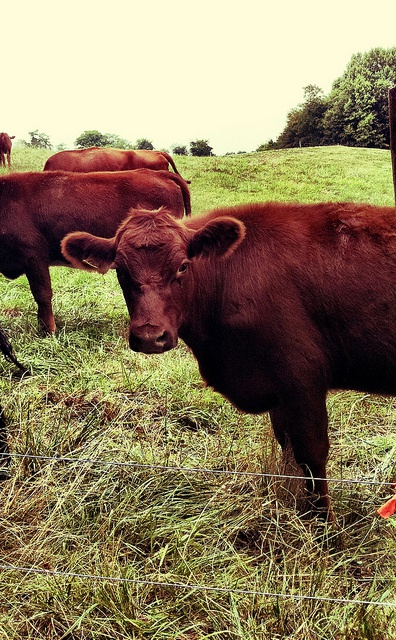Describe the objects in this image and their specific colors. I can see cow in lightyellow, black, maroon, and brown tones, cow in lightyellow, maroon, black, and brown tones, cow in lightyellow, brown, maroon, and tan tones, and cow in lightyellow, maroon, brown, and black tones in this image. 